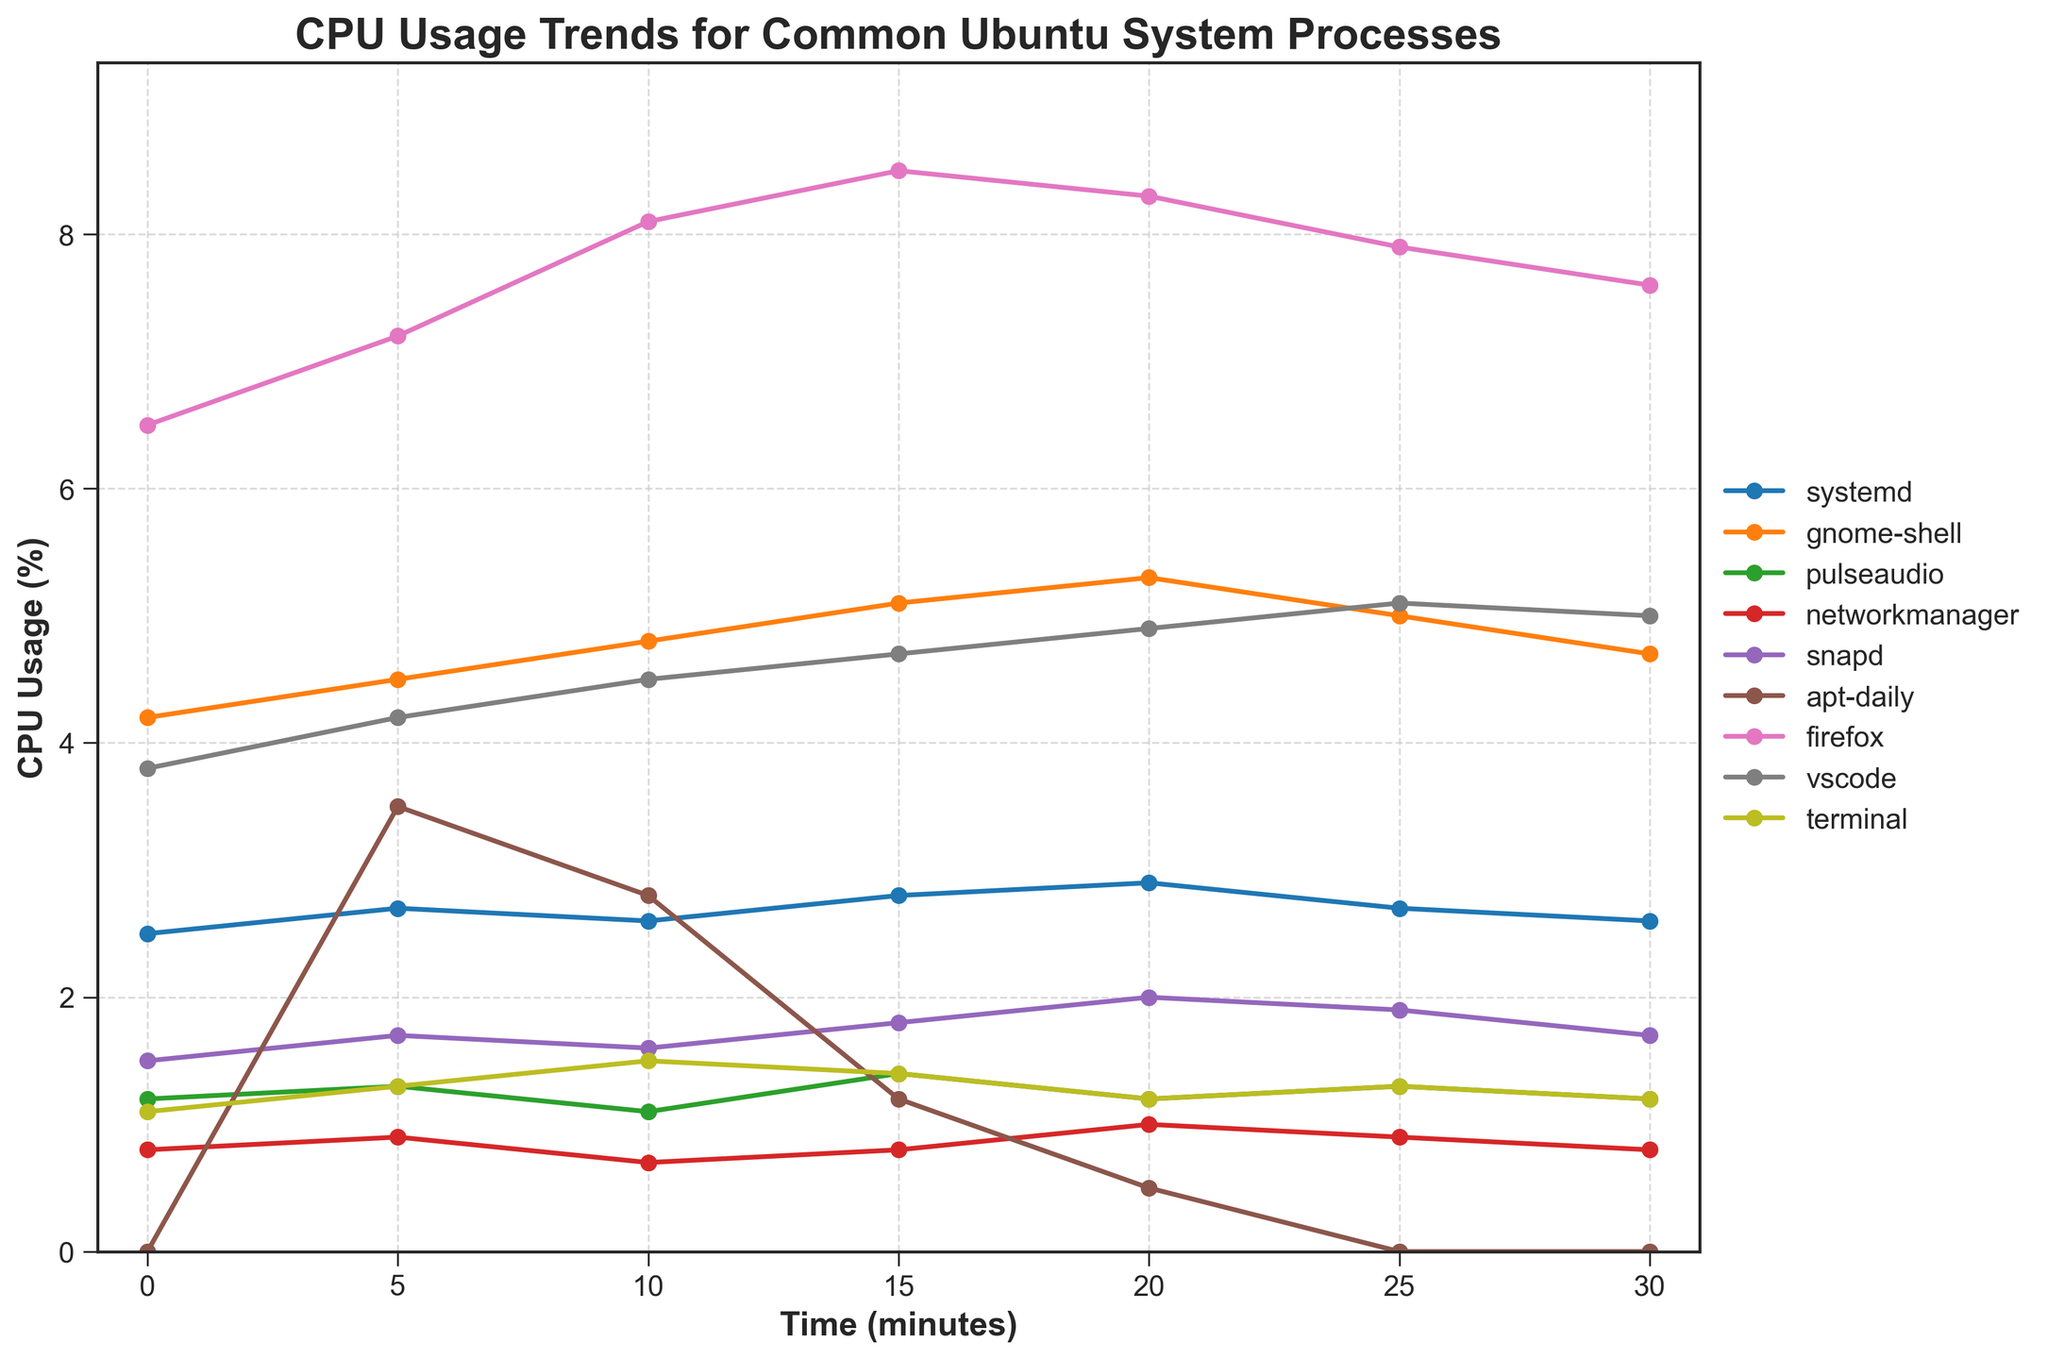Which process has the highest CPU usage at the 10-minute mark? Identify the point on the graph corresponding to the 10-minute mark and compare the CPU usage values of all processes at this time point.
Answer: Firefox Which process shows the most fluctuation in CPU usage over the 30 minutes? Evaluate the range (difference between the maximum and minimum values) of CPU usage for each process. The process with the largest range shows the most fluctuation.
Answer: apt-daily At what time does 'gnome-shell' have its peak CPU usage? For the 'gnome-shell', find the maximum CPU usage value and identify the corresponding time point.
Answer: 20 minutes How does the CPU usage of 'systemd' change from 0 to 30 minutes? Identify the CPU usage values of 'systemd' at 0 and 30 minutes from the graph and calculate the difference.
Answer: Increases by 0.1% Which two processes have the closest CPU usage at the 25-minute mark? Compare the CPU usage values of all processes at the 25-minute mark and find the pair with the smallest difference.
Answer: pulseaudio and terminal Is there any process whose CPU usage hits zero after it starts above zero? Check each process line to see if it starts above zero and hits zero later on.
Answer: apt-daily What is the trend of 'firefox' CPU usage from 0 to 30 minutes? Examine how 'firefox' CPU usage values change over the time points, noting if it increases, decreases, or remains constant.
Answer: Generally decreases after 15 min Which process has the most steady CPU usage over 30 minutes? Evaluate the variation in CPU usage values for each process. The process with the least change is the most steady.
Answer: pulseaudio 